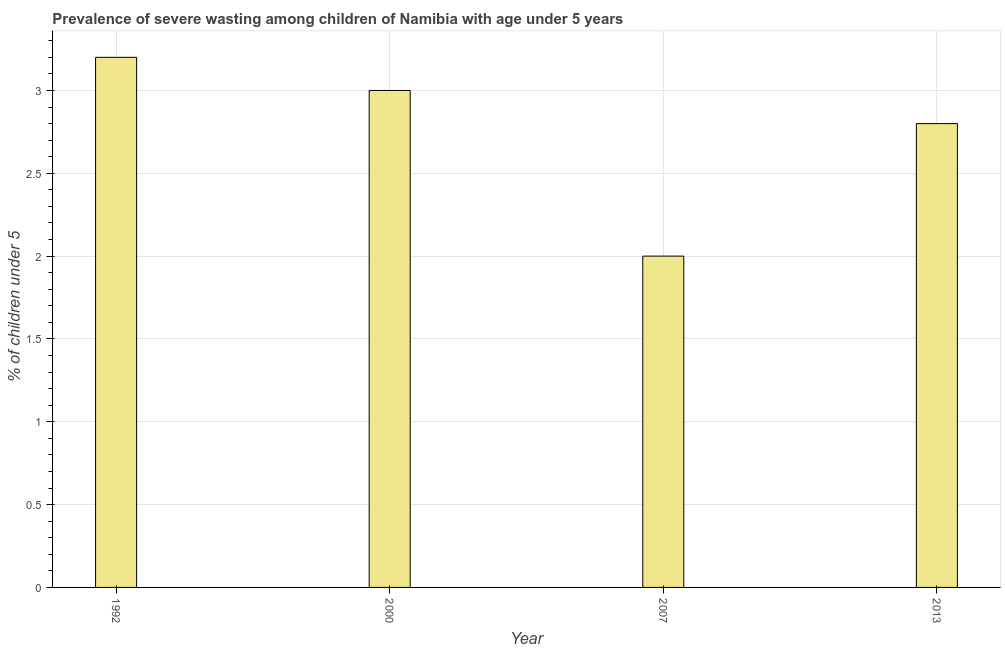Does the graph contain any zero values?
Offer a terse response. No. Does the graph contain grids?
Your answer should be very brief. Yes. What is the title of the graph?
Make the answer very short. Prevalence of severe wasting among children of Namibia with age under 5 years. What is the label or title of the Y-axis?
Keep it short and to the point.  % of children under 5. What is the prevalence of severe wasting in 2013?
Give a very brief answer. 2.8. Across all years, what is the maximum prevalence of severe wasting?
Provide a succinct answer. 3.2. Across all years, what is the minimum prevalence of severe wasting?
Your answer should be very brief. 2. In which year was the prevalence of severe wasting maximum?
Your answer should be compact. 1992. In which year was the prevalence of severe wasting minimum?
Provide a succinct answer. 2007. What is the difference between the prevalence of severe wasting in 1992 and 2000?
Your response must be concise. 0.2. What is the average prevalence of severe wasting per year?
Your answer should be very brief. 2.75. What is the median prevalence of severe wasting?
Keep it short and to the point. 2.9. In how many years, is the prevalence of severe wasting greater than 1.7 %?
Offer a very short reply. 4. Do a majority of the years between 1992 and 2013 (inclusive) have prevalence of severe wasting greater than 2.5 %?
Ensure brevity in your answer.  Yes. What is the ratio of the prevalence of severe wasting in 1992 to that in 2000?
Your response must be concise. 1.07. Is the prevalence of severe wasting in 2000 less than that in 2013?
Offer a very short reply. No. Is the difference between the prevalence of severe wasting in 2000 and 2007 greater than the difference between any two years?
Provide a succinct answer. No. Is the sum of the prevalence of severe wasting in 1992 and 2007 greater than the maximum prevalence of severe wasting across all years?
Keep it short and to the point. Yes. What is the difference between the highest and the lowest prevalence of severe wasting?
Your answer should be compact. 1.2. In how many years, is the prevalence of severe wasting greater than the average prevalence of severe wasting taken over all years?
Offer a very short reply. 3. How many bars are there?
Make the answer very short. 4. How many years are there in the graph?
Offer a terse response. 4. What is the difference between two consecutive major ticks on the Y-axis?
Ensure brevity in your answer.  0.5. Are the values on the major ticks of Y-axis written in scientific E-notation?
Provide a short and direct response. No. What is the  % of children under 5 in 1992?
Your answer should be very brief. 3.2. What is the  % of children under 5 of 2007?
Offer a terse response. 2. What is the  % of children under 5 in 2013?
Your response must be concise. 2.8. What is the difference between the  % of children under 5 in 1992 and 2013?
Ensure brevity in your answer.  0.4. What is the difference between the  % of children under 5 in 2000 and 2007?
Offer a terse response. 1. What is the ratio of the  % of children under 5 in 1992 to that in 2000?
Your answer should be very brief. 1.07. What is the ratio of the  % of children under 5 in 1992 to that in 2007?
Offer a very short reply. 1.6. What is the ratio of the  % of children under 5 in 1992 to that in 2013?
Ensure brevity in your answer.  1.14. What is the ratio of the  % of children under 5 in 2000 to that in 2013?
Give a very brief answer. 1.07. What is the ratio of the  % of children under 5 in 2007 to that in 2013?
Offer a very short reply. 0.71. 